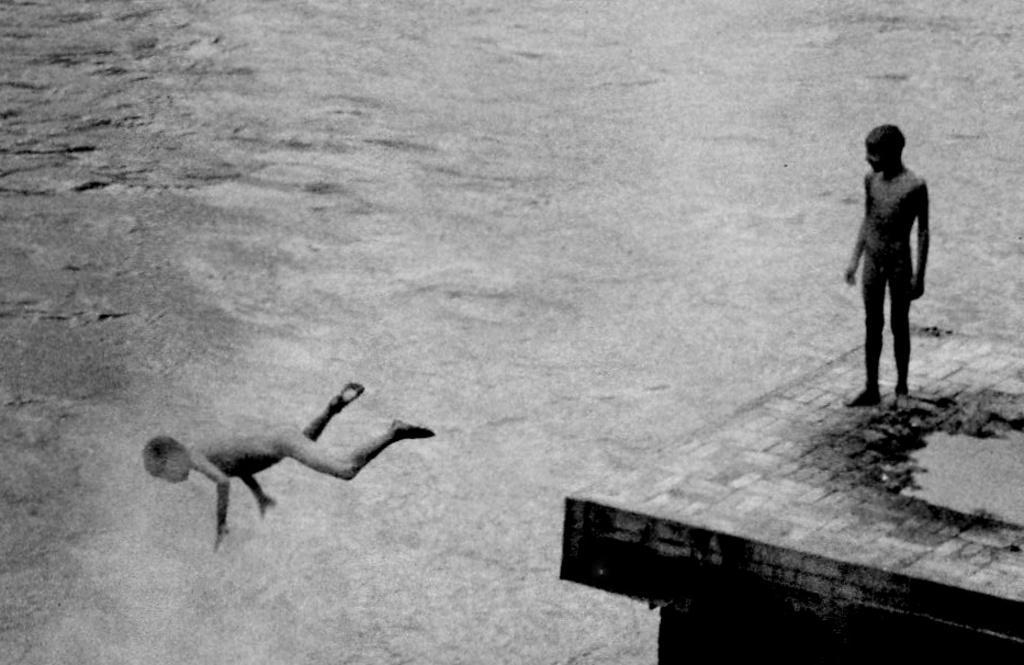Could you give a brief overview of what you see in this image? This is a black and white image. There are two kids. There is water. There is a platform. 